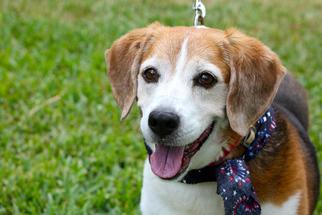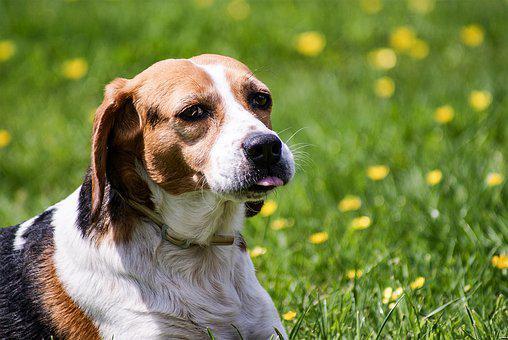The first image is the image on the left, the second image is the image on the right. Considering the images on both sides, is "At least one dog wears something around his neck." valid? Answer yes or no. Yes. 